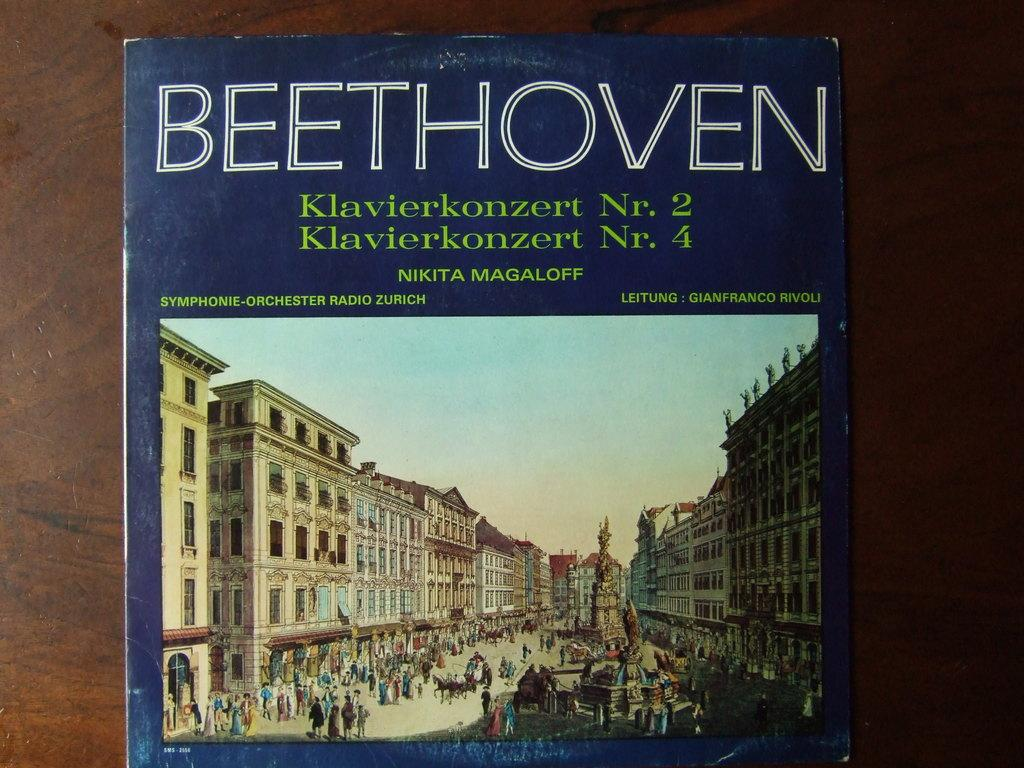Provide a one-sentence caption for the provided image. A blue book has the BEETHOVEN on the top and buildings on the photo. 